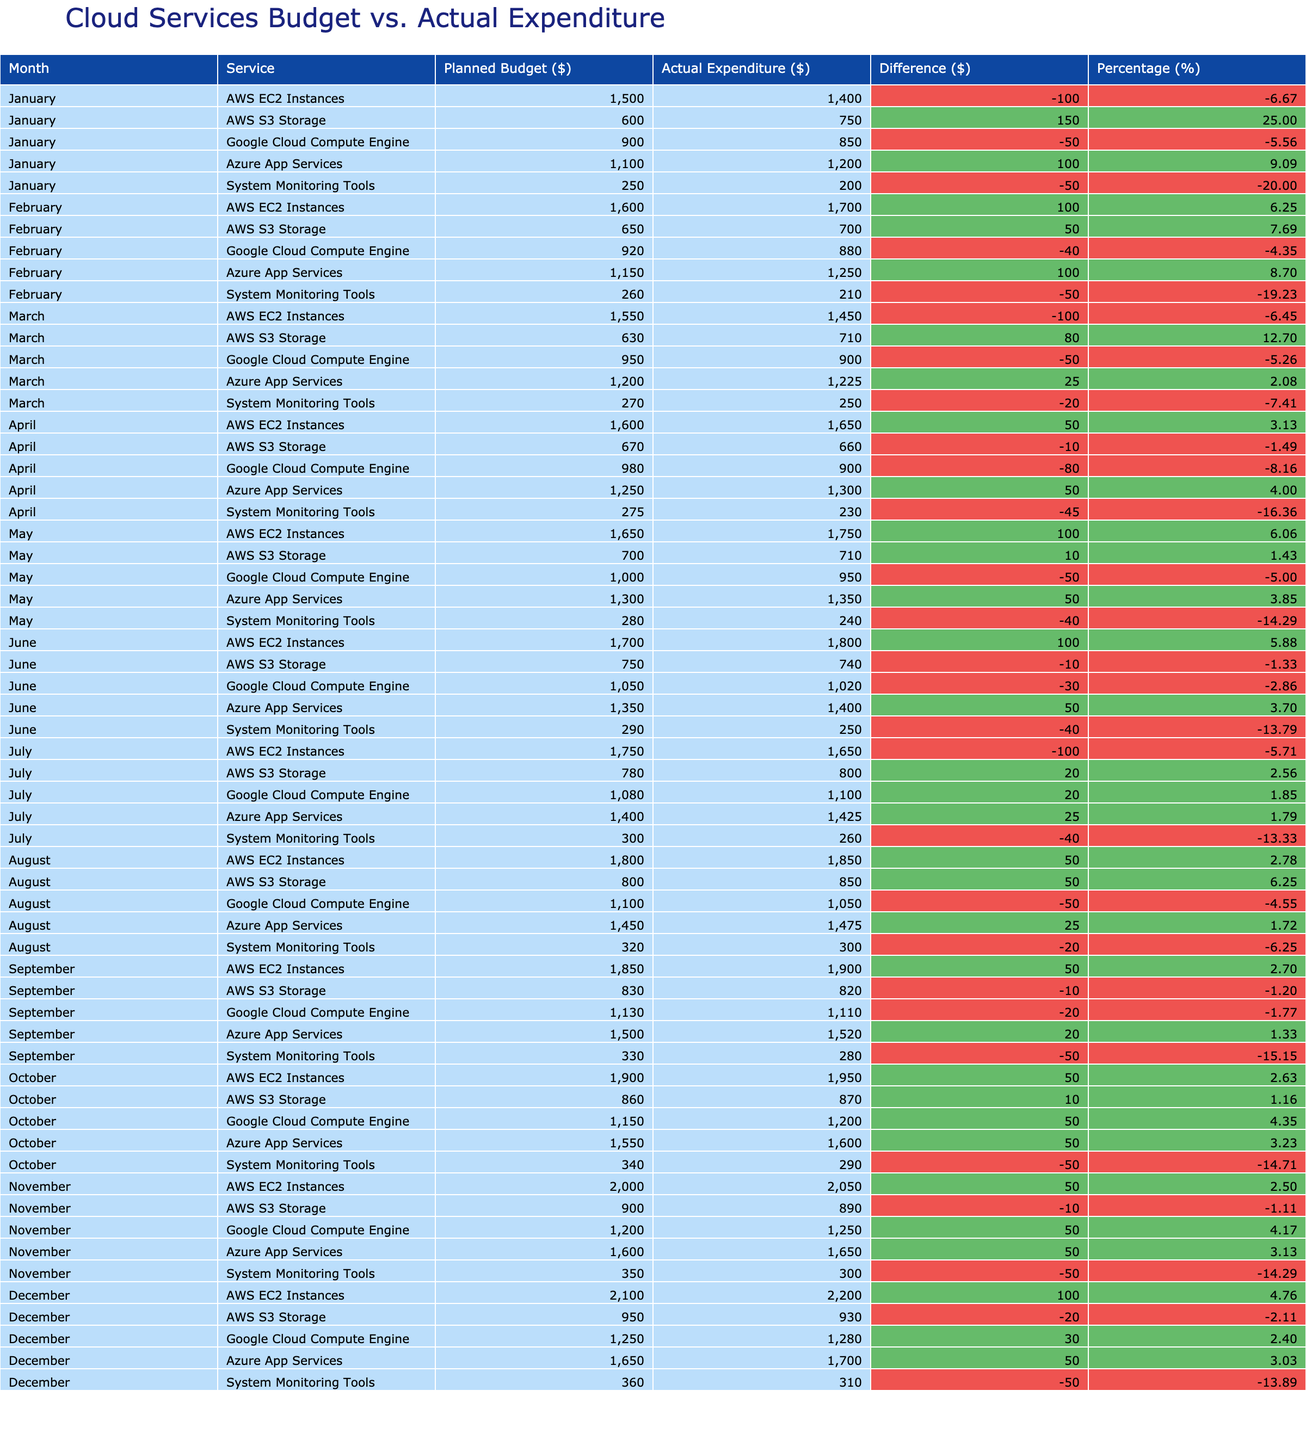What is the total actual expenditure on AWS EC2 Instances from January to December? The values in the "Actual Expenditure ($)" column for AWS EC2 Instances from January to December are 1400, 1700, 1450, 1650, 1750, 1800, 1650, 1850, 1900, 1950, 2050, and 2200. Adding these together gives a total of 1400 + 1700 + 1450 + 1650 + 1750 + 1800 + 1650 + 1850 + 1900 + 1950 + 2050 + 2200 = 19600.
Answer: 19600 Which month had the highest planned budget for Azure App Services? In the "Planned Budget ($)" column for Azure App Services, the values are 1100, 1150, 1200, 1250, 1300, 1350, 1400, 1450, 1500, 1550, 1600, and 1650 from January to December. The highest value is 1650 in December.
Answer: December Did the actual expenditure exceed the planned budget for Google Cloud Compute Engine in any month? Looking at the records for Google Cloud Compute Engine, the actual expenditures are 850, 880, 900, 900, 950, 1020, 1100, 1050, 1110, 1200, 1250, and 1280 for each month. In all cases, the planned budgets were 900, 920, 950, 980, 1000, 1050, 1080, 1100, 1130, 1150, 1200, and 1250. The actual expenditures exceeded the planned budget in February, March, October, November, and December.
Answer: Yes What is the average percentage difference between planned budget and actual expenditure for AWS S3 Storage across all months? The "Difference" for AWS S3 Storage is calculated for each month, and the values are -150, -50, 80, -10, 10, -10, 20, 50, -10, 10, -10, -20. Converting these into percentage differences using the planned budgets (600, 650, 670, 680, 700, 750, 780, 800, 830, 860, 900, 950), we find percentages for each month. Adding these percentages and dividing by 12 gives an average of around -0.42.
Answer: -0.42 Which service had the lowest actual expenditure in any month? By scanning through the "Actual Expenditure ($)" column, the lowest value for all services in any month is 200 for System Monitoring Tools in January.
Answer: 200 Determine if the actual expenditure for Azure App Services increased from January to February. The actual expenditures in January and February for Azure App Services are 1200 and 1250 respectively. Since 1250 is greater than 1200, the expenditure did increase.
Answer: Yes 